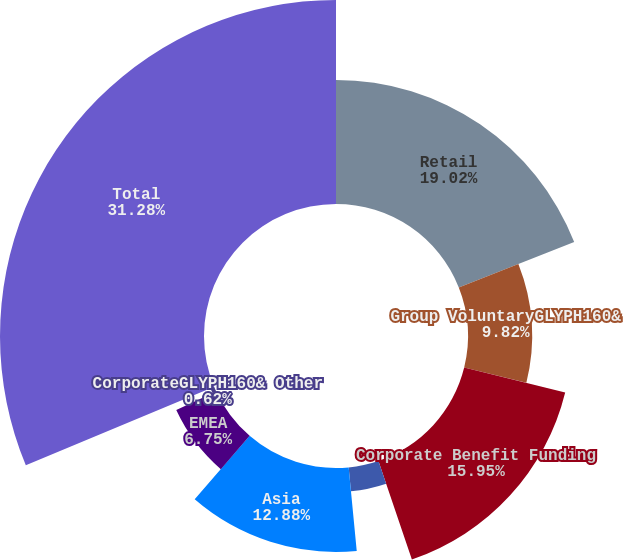Convert chart to OTSL. <chart><loc_0><loc_0><loc_500><loc_500><pie_chart><fcel>Retail<fcel>Group VoluntaryGLYPH160&<fcel>Corporate Benefit Funding<fcel>Latin America<fcel>Asia<fcel>EMEA<fcel>CorporateGLYPH160& Other<fcel>Total<nl><fcel>19.02%<fcel>9.82%<fcel>15.95%<fcel>3.68%<fcel>12.88%<fcel>6.75%<fcel>0.62%<fcel>31.28%<nl></chart> 